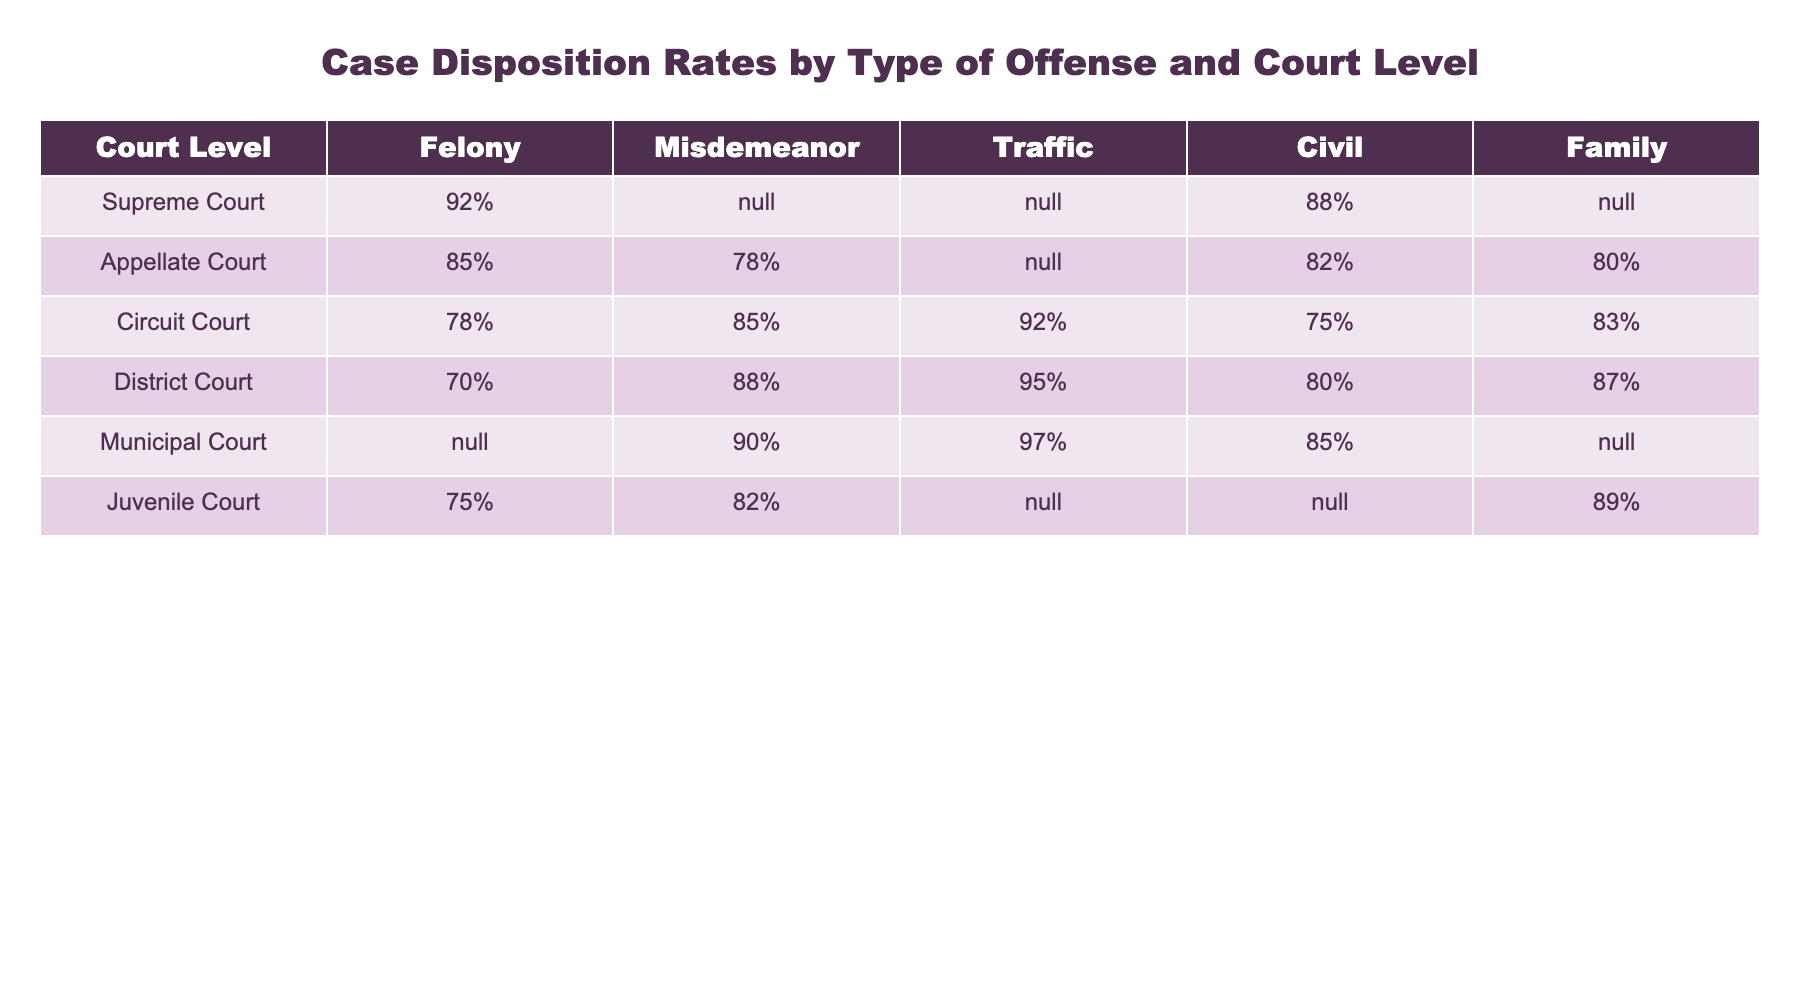What is the case disposition rate for felonies in the Supreme Court? Referring to the table, the case disposition rate for felonies in the Supreme Court is listed as 92%.
Answer: 92% Which court has the highest case disposition rate for misdemeanors? The table shows that the District Court has the highest case disposition rate for misdemeanors at 88%.
Answer: District Court Is there a case disposition rate for traffic offenses in the Appellate Court? The table indicates that traffic offenses do not have a case disposition rate listed for the Appellate Court, which is marked as N/A.
Answer: No What is the average case disposition rate for civil cases across all court levels that have data? The civil case disposition rates are 88% (Supreme Court), 82% (Appellate Court), 75% (Circuit Court), 80% (District Court), and 85% (Municipal Court). Calculating the average: (88 + 82 + 75 + 80 + 85) / 5 = 82.
Answer: 82% Which court has a higher disposition rate for traffic offenses, Circuit Court or District Court? The Circuit Court has a disposition rate of 92% for traffic offenses, while the District Court has a rate of 95%. Therefore, the District Court has a higher rate.
Answer: District Court Does the Juvenile Court have a disposition rate for civil cases? The table shows that the Juvenile Court does not have a disposition rate listed for civil cases, marked as N/A.
Answer: No What is the disposition rate for family cases in the Appellate Court compared to the Circuit Court? The Appellate Court has a disposition rate of 80% for family cases, while the Circuit Court has a rate of 83%. Comparing these, the Circuit Court has a higher rate.
Answer: Circuit Court If we consider the Supreme Court and the Municipal Court, which court has a higher disposition rate for civil cases? The Supreme Court has a disposition rate of 88% for civil cases, while the Municipal Court has a rate of 85%. Comparing these rates, the Supreme Court has a higher rate.
Answer: Supreme Court What can we infer about the disposition rate trends between felony and misdemeanor cases in the Circuit Court? The disposition rates for the Circuit Court are 78% for felonies and 85% for misdemeanors. This indicates that misdemeanor cases are disposed of at a higher rate than felony cases in that court.
Answer: Misdemeanors are higher 